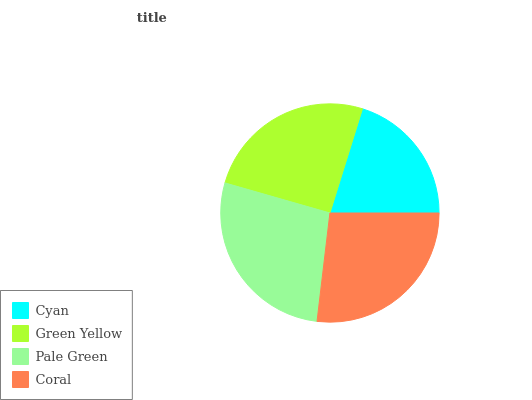Is Cyan the minimum?
Answer yes or no. Yes. Is Pale Green the maximum?
Answer yes or no. Yes. Is Green Yellow the minimum?
Answer yes or no. No. Is Green Yellow the maximum?
Answer yes or no. No. Is Green Yellow greater than Cyan?
Answer yes or no. Yes. Is Cyan less than Green Yellow?
Answer yes or no. Yes. Is Cyan greater than Green Yellow?
Answer yes or no. No. Is Green Yellow less than Cyan?
Answer yes or no. No. Is Coral the high median?
Answer yes or no. Yes. Is Green Yellow the low median?
Answer yes or no. Yes. Is Cyan the high median?
Answer yes or no. No. Is Coral the low median?
Answer yes or no. No. 